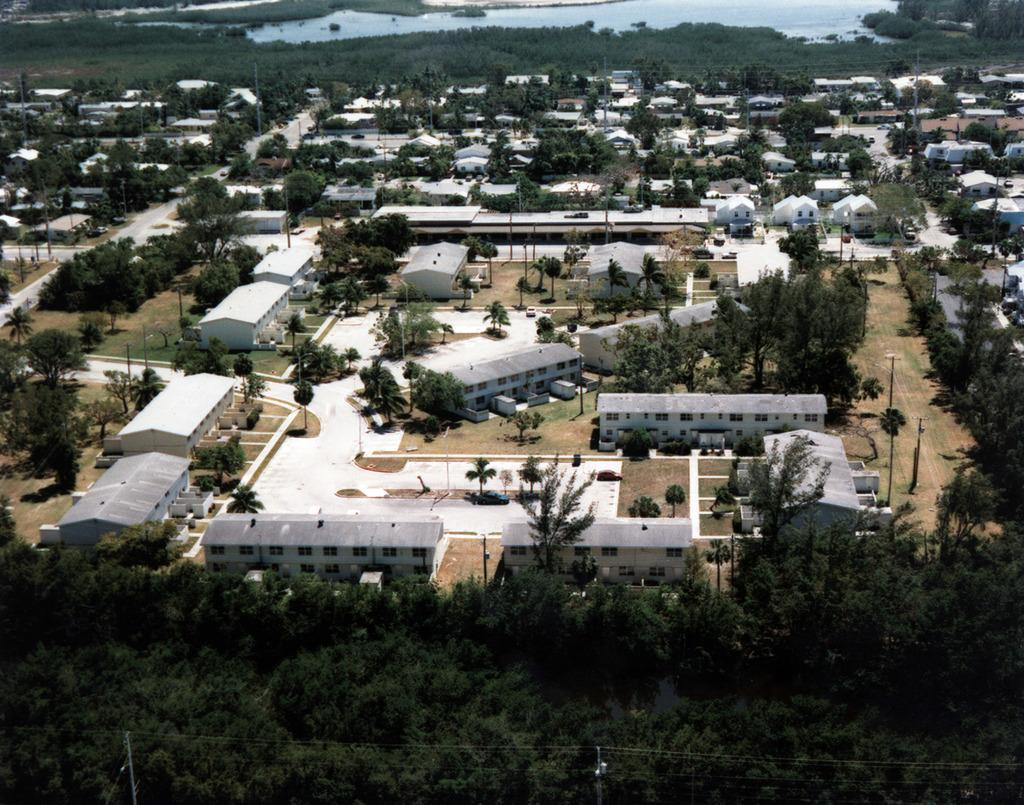What type of structures can be seen in the image? There is a group of buildings in the image. What natural elements are visible in the image? There are trees and a lake visible in the image. What type of infrastructure is present in the image? Power line cables and poles are visible in the image. Where is the bun being sold in the image? There is no bun or market present in the image. What type of grass is growing near the lake in the image? There is no grass visible near the lake in the image. 